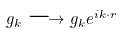<formula> <loc_0><loc_0><loc_500><loc_500>g _ { k } \longrightarrow g _ { k } e ^ { i k \cdot r }</formula> 